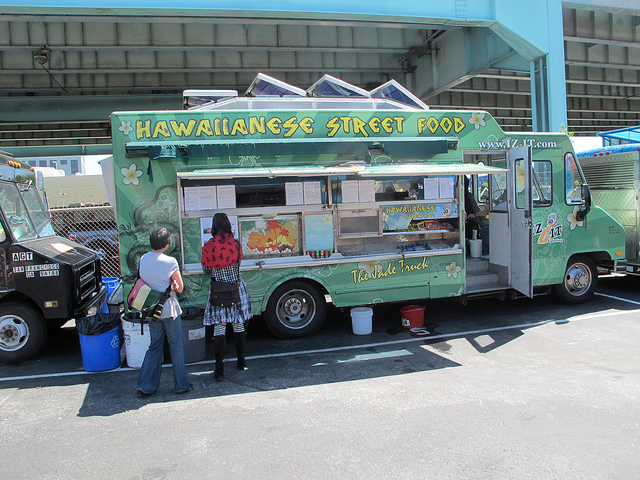Identify the text contained in this image. HAWAIIANESE STREET FOOD WWW.IZ.IT.com Thade Z AGT Jade 